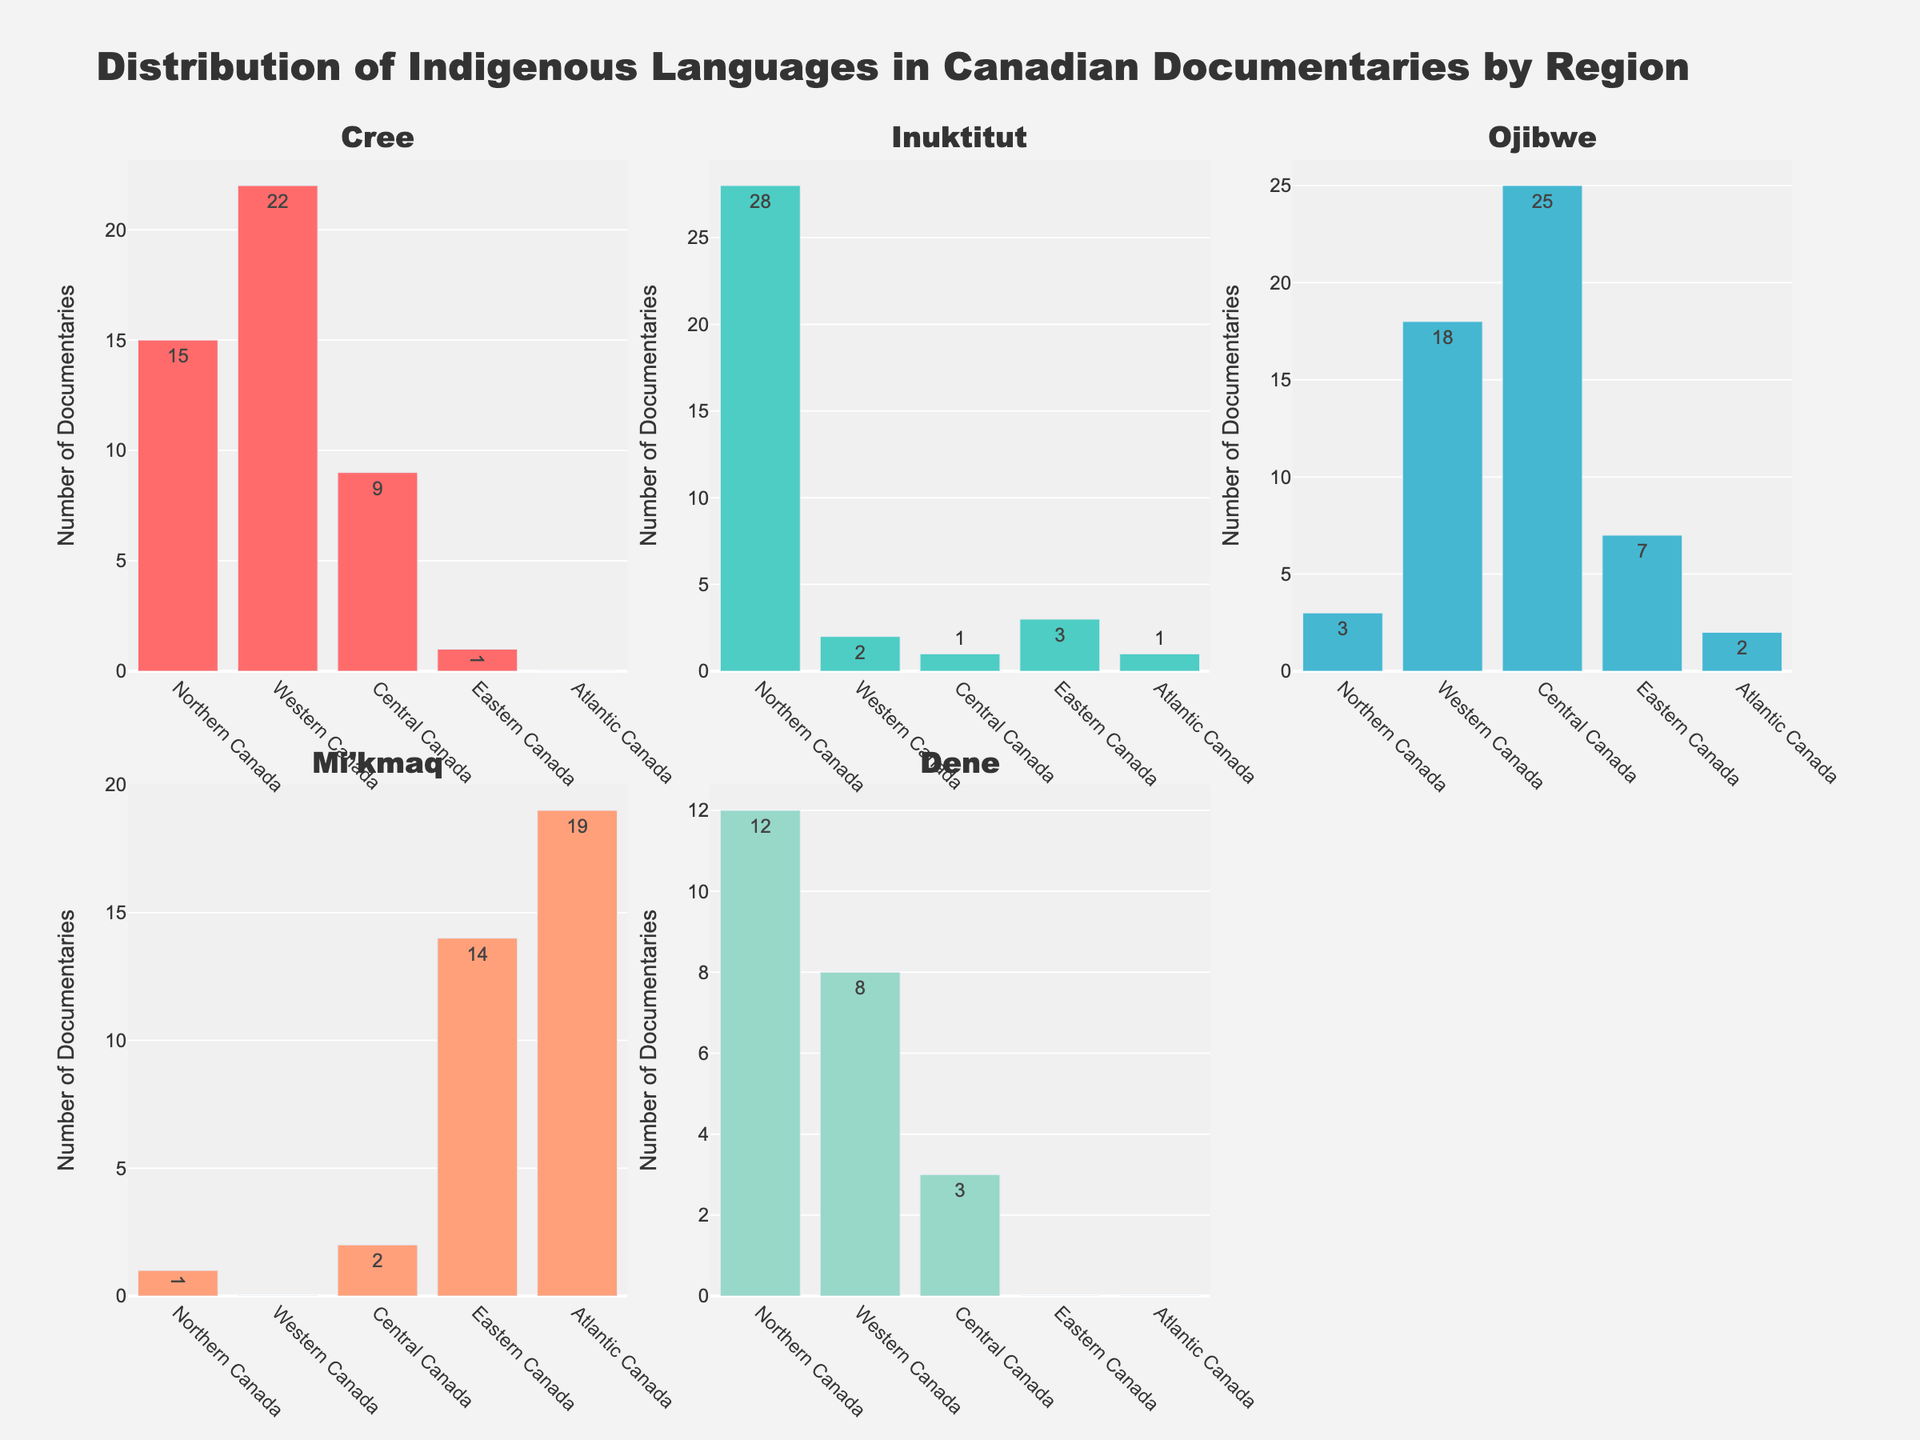What is the title of the figure? The title is typically found at the top of the figure. It helps to understand the overall subject covered by the visualizations.
Answer: Distribution of Indigenous Languages in Canadian Documentaries by Region Which region has the highest number of documentaries featuring the Cree language? By examining the bar heights in the subplot for Cree, the highest bar corresponds to the data point for Western Canada.
Answer: Western Canada How many documentaries feature the Inuktitut language across all regions? To find the total, sum the values of all the bars in the Inuktitut subplot: 28 (Northern Canada) + 2 (Western Canada) + 1 (Central Canada) + 3 (Eastern Canada) + 1 (Atlantic Canada) = 35.
Answer: 35 Which indigenous language is least featured in documentaries across Northern Canada? In the subplot for Northern Canada, identify the bar with the smallest height. This indicates the least featured language. The smallest bar is for Mi'kmaq.
Answer: Mi'kmaq Compare the number of documentaries featuring the Mi'kmaq language in Atlantic Canada to Eastern Canada. Which region has more? Look at the Mi'kmaq subplots for both regions. Atlantic Canada's bar is higher (19) than Eastern Canada's (14), so Atlantic Canada has more.
Answer: Atlantic Canada What is the sum of documentaries featuring the Dene language in Western and Northern Canada? Add the number of documentaries for Dene from both Western (8) and Northern (12) Canada: 12 + 8 = 20.
Answer: 20 Which region has the smallest number of documentaries featuring Ojibwe? By comparing the lengths of the bars in the Ojibwe subplot across all regions, Northern Canada (3) has the smallest.
Answer: Northern Canada How many more documentaries feature the Cree language in Western Canada compared to Central Canada? Subtract the number of documentaries in Central Canada (9) from Western Canada (22) for Cree: 22 - 9 = 13.
Answer: 13 Is the number of documentaries featuring the Inuktitut language higher in Northern Canada than in all other regions combined? Northern Canada has 28 documentaries featuring Inuktitut. The combined total for other regions is 2 (Western) + 1 (Central) + 3 (Eastern) + 1 (Atlantic) = 7. Since 28 > 7, Northern Canada has more.
Answer: Yes 